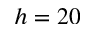Convert formula to latex. <formula><loc_0><loc_0><loc_500><loc_500>h = 2 0</formula> 